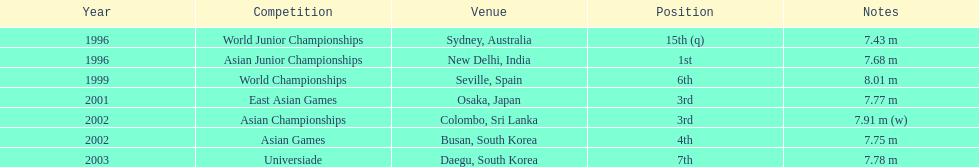What is the distinction between the number of times the third position was attained and the number of times the first position was reached? 1. 